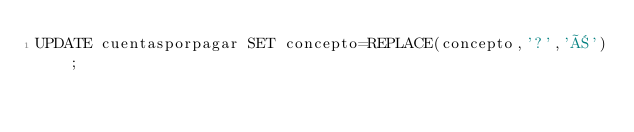Convert code to text. <code><loc_0><loc_0><loc_500><loc_500><_SQL_>UPDATE cuentasporpagar SET concepto=REPLACE(concepto,'?','Ñ');</code> 